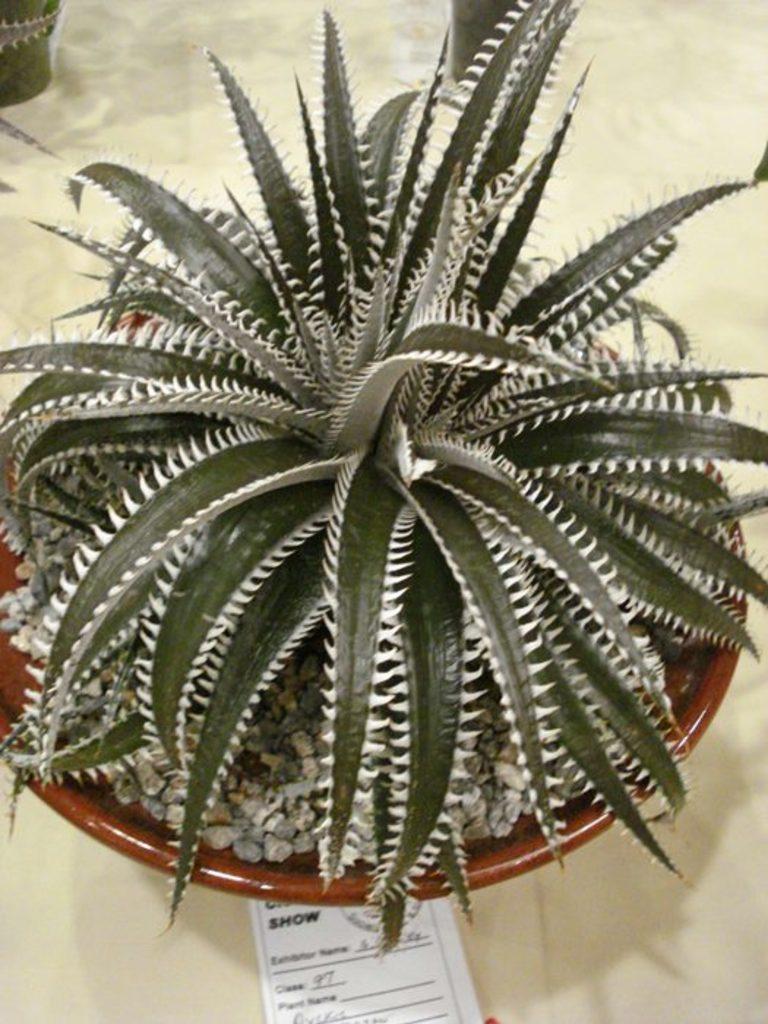Could you give a brief overview of what you see in this image? In the center of the image there is a house plant placed on the table. 